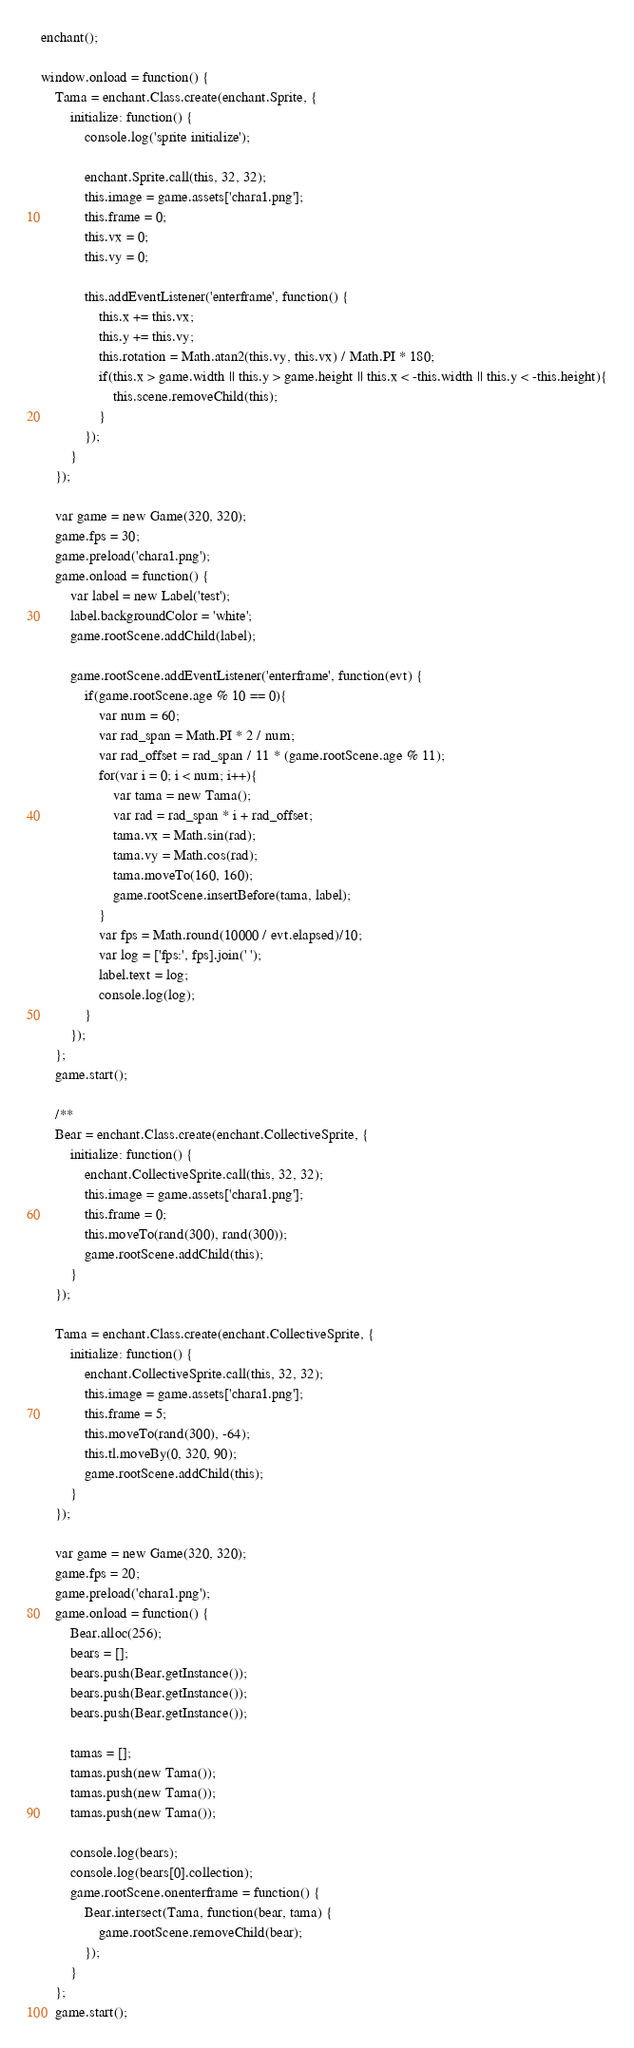Convert code to text. <code><loc_0><loc_0><loc_500><loc_500><_JavaScript_>enchant();

window.onload = function() {
    Tama = enchant.Class.create(enchant.Sprite, {
        initialize: function() {
            console.log('sprite initialize');

            enchant.Sprite.call(this, 32, 32);
            this.image = game.assets['chara1.png'];
            this.frame = 0;
            this.vx = 0;
            this.vy = 0;

            this.addEventListener('enterframe', function() {
                this.x += this.vx;
                this.y += this.vy;
                this.rotation = Math.atan2(this.vy, this.vx) / Math.PI * 180;
                if(this.x > game.width || this.y > game.height || this.x < -this.width || this.y < -this.height){
                    this.scene.removeChild(this);
                }
            });
        }
    });

    var game = new Game(320, 320);
    game.fps = 30;
    game.preload('chara1.png');
    game.onload = function() {
        var label = new Label('test');
        label.backgroundColor = 'white';
        game.rootScene.addChild(label);

        game.rootScene.addEventListener('enterframe', function(evt) {
            if(game.rootScene.age % 10 == 0){
                var num = 60;
                var rad_span = Math.PI * 2 / num;
                var rad_offset = rad_span / 11 * (game.rootScene.age % 11);
                for(var i = 0; i < num; i++){
                    var tama = new Tama();
                    var rad = rad_span * i + rad_offset;
                    tama.vx = Math.sin(rad);
                    tama.vy = Math.cos(rad);
                    tama.moveTo(160, 160);
                    game.rootScene.insertBefore(tama, label);
                }
                var fps = Math.round(10000 / evt.elapsed)/10;
                var log = ['fps:', fps].join(' ');
                label.text = log;
                console.log(log);
            }
        });
    };
    game.start();

    /**
    Bear = enchant.Class.create(enchant.CollectiveSprite, {
        initialize: function() {
            enchant.CollectiveSprite.call(this, 32, 32);
            this.image = game.assets['chara1.png'];
            this.frame = 0;
            this.moveTo(rand(300), rand(300));
            game.rootScene.addChild(this);
        }
    });

    Tama = enchant.Class.create(enchant.CollectiveSprite, {
        initialize: function() {
            enchant.CollectiveSprite.call(this, 32, 32);
            this.image = game.assets['chara1.png'];
            this.frame = 5;
            this.moveTo(rand(300), -64);
            this.tl.moveBy(0, 320, 90);
            game.rootScene.addChild(this);
        }
    });

    var game = new Game(320, 320);
    game.fps = 20;
    game.preload('chara1.png');
    game.onload = function() {
        Bear.alloc(256);
        bears = [];
        bears.push(Bear.getInstance());
        bears.push(Bear.getInstance());
        bears.push(Bear.getInstance());

        tamas = [];
        tamas.push(new Tama());
        tamas.push(new Tama());
        tamas.push(new Tama());

        console.log(bears);
        console.log(bears[0].collection);
        game.rootScene.onenterframe = function() {
            Bear.intersect(Tama, function(bear, tama) {
                game.rootScene.removeChild(bear);
            });
        }
    };
    game.start();
</code> 